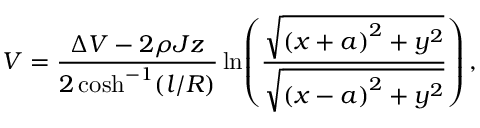Convert formula to latex. <formula><loc_0><loc_0><loc_500><loc_500>V = \frac { \Delta V - 2 \rho J z } { 2 \cosh ^ { - 1 } ( l / R ) } \ln \, \left ( \frac { \sqrt { \left ( x + a \right ) ^ { 2 } + y ^ { 2 } } } { \sqrt { \left ( x - a \right ) ^ { 2 } + y ^ { 2 } } } \right ) ,</formula> 